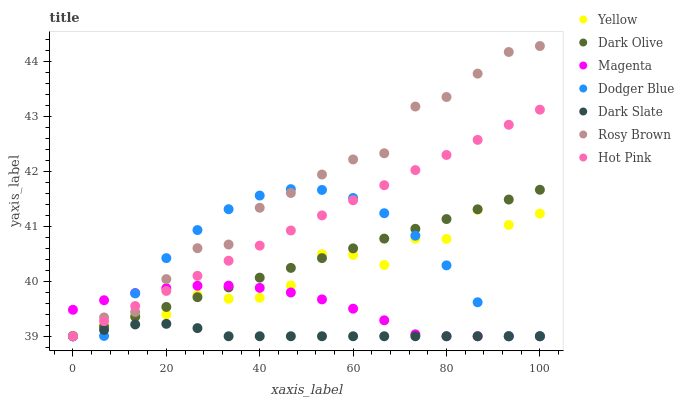Does Dark Slate have the minimum area under the curve?
Answer yes or no. Yes. Does Rosy Brown have the maximum area under the curve?
Answer yes or no. Yes. Does Dark Olive have the minimum area under the curve?
Answer yes or no. No. Does Dark Olive have the maximum area under the curve?
Answer yes or no. No. Is Hot Pink the smoothest?
Answer yes or no. Yes. Is Yellow the roughest?
Answer yes or no. Yes. Is Dark Olive the smoothest?
Answer yes or no. No. Is Dark Olive the roughest?
Answer yes or no. No. Does Rosy Brown have the lowest value?
Answer yes or no. Yes. Does Yellow have the lowest value?
Answer yes or no. No. Does Rosy Brown have the highest value?
Answer yes or no. Yes. Does Dark Olive have the highest value?
Answer yes or no. No. Is Dark Slate less than Yellow?
Answer yes or no. Yes. Is Yellow greater than Dark Slate?
Answer yes or no. Yes. Does Rosy Brown intersect Dodger Blue?
Answer yes or no. Yes. Is Rosy Brown less than Dodger Blue?
Answer yes or no. No. Is Rosy Brown greater than Dodger Blue?
Answer yes or no. No. Does Dark Slate intersect Yellow?
Answer yes or no. No. 